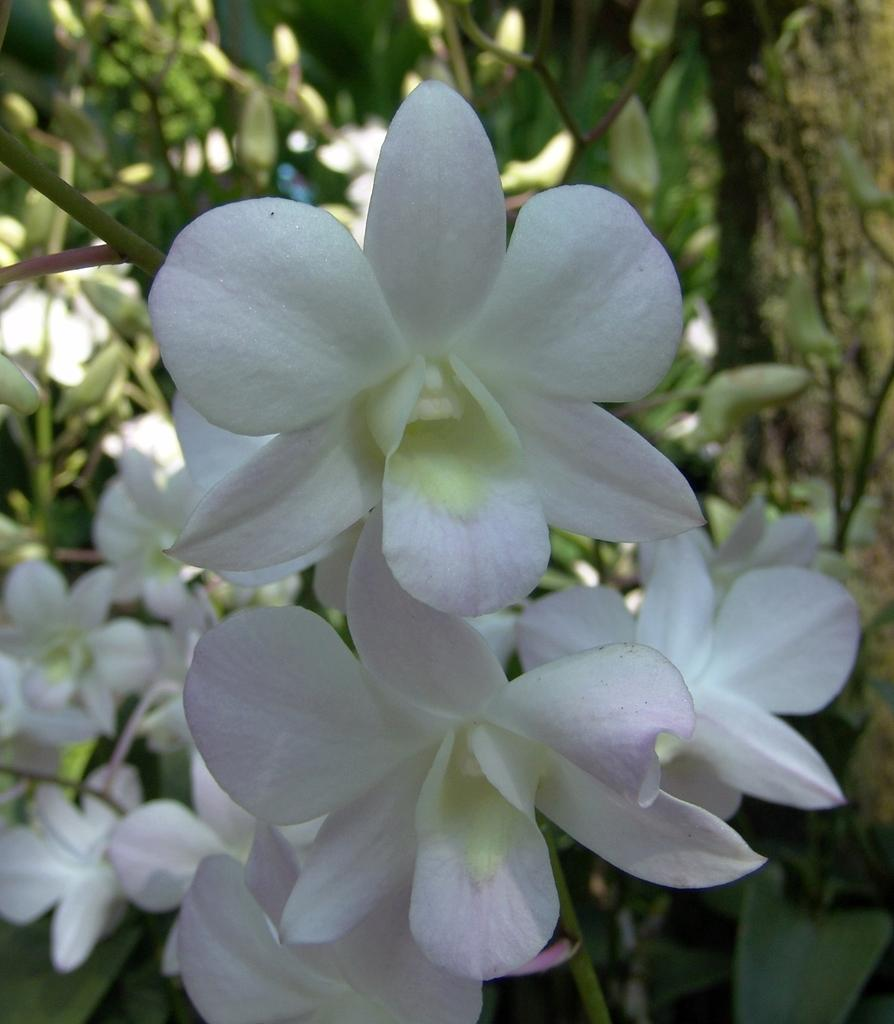What type of flora is present in the image? There are flowers in the image. Can you describe the colors of the flowers? The flowers are white and pale pink in color. What else is associated with the flowers in the image? There are leaves associated with the flowers. What decision does the tin make in the image? There is no tin present in the image, so it cannot make any decisions. 